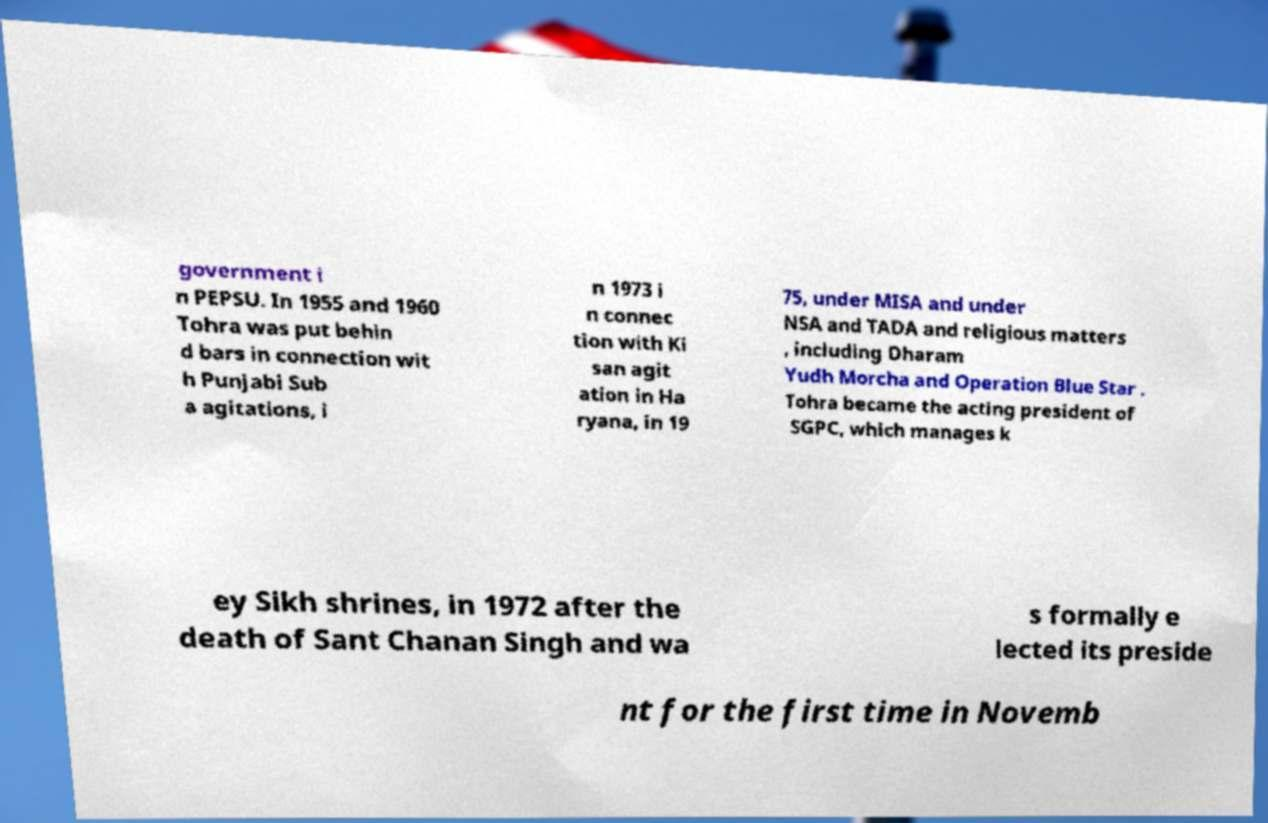Please identify and transcribe the text found in this image. government i n PEPSU. In 1955 and 1960 Tohra was put behin d bars in connection wit h Punjabi Sub a agitations, i n 1973 i n connec tion with Ki san agit ation in Ha ryana, in 19 75, under MISA and under NSA and TADA and religious matters , including Dharam Yudh Morcha and Operation Blue Star . Tohra became the acting president of SGPC, which manages k ey Sikh shrines, in 1972 after the death of Sant Chanan Singh and wa s formally e lected its preside nt for the first time in Novemb 